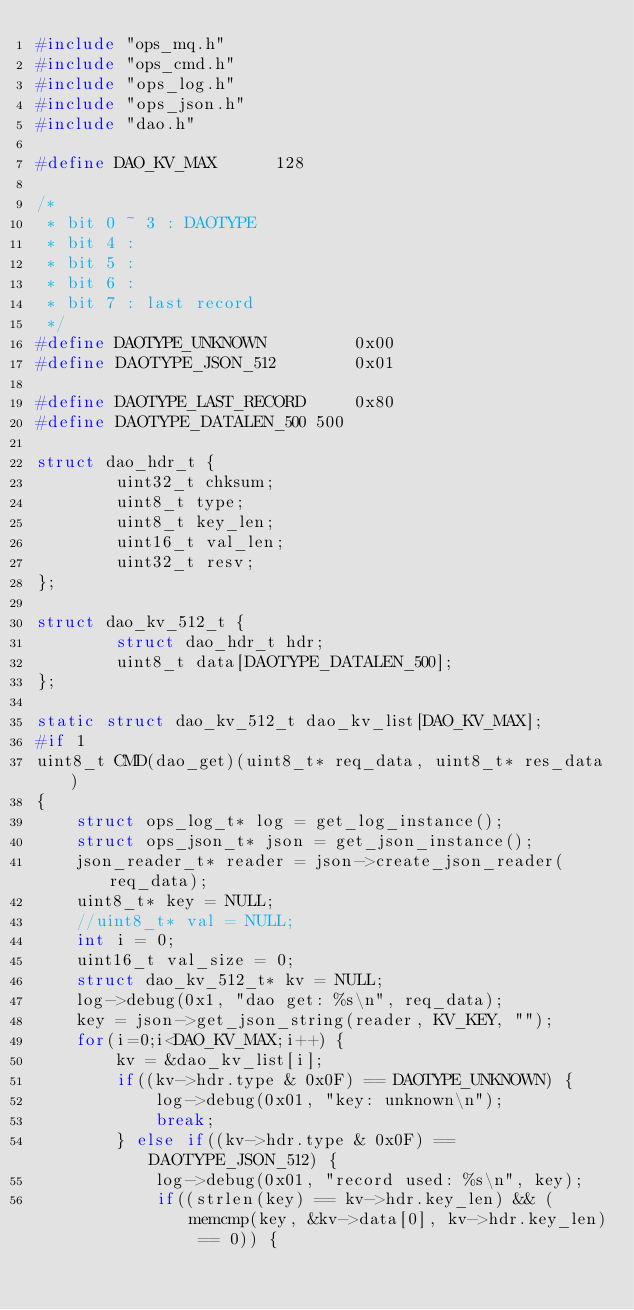Convert code to text. <code><loc_0><loc_0><loc_500><loc_500><_C_>#include "ops_mq.h"
#include "ops_cmd.h"
#include "ops_log.h"
#include "ops_json.h"
#include "dao.h"

#define DAO_KV_MAX      128

/*
 * bit 0 ~ 3 : DAOTYPE
 * bit 4 :
 * bit 5 :
 * bit 6 :
 * bit 7 : last record
 */
#define DAOTYPE_UNKNOWN         0x00
#define DAOTYPE_JSON_512        0x01

#define DAOTYPE_LAST_RECORD     0x80
#define DAOTYPE_DATALEN_500	500

struct dao_hdr_t {
        uint32_t chksum;
        uint8_t type;
        uint8_t key_len;
        uint16_t val_len;
        uint32_t resv;
};

struct dao_kv_512_t {
        struct dao_hdr_t hdr;
        uint8_t data[DAOTYPE_DATALEN_500];
};

static struct dao_kv_512_t dao_kv_list[DAO_KV_MAX];
#if 1
uint8_t CMD(dao_get)(uint8_t* req_data, uint8_t* res_data)
{
	struct ops_log_t* log = get_log_instance();
	struct ops_json_t* json = get_json_instance();
	json_reader_t* reader = json->create_json_reader(req_data);
	uint8_t* key = NULL;
	//uint8_t* val = NULL;
	int i = 0;
	uint16_t val_size = 0;
	struct dao_kv_512_t* kv = NULL;
	log->debug(0x1, "dao get: %s\n", req_data);
	key = json->get_json_string(reader, KV_KEY, "");
	for(i=0;i<DAO_KV_MAX;i++) {
		kv = &dao_kv_list[i];
		if((kv->hdr.type & 0x0F) == DAOTYPE_UNKNOWN) {
			log->debug(0x01, "key: unknown\n");
			break;
		} else if((kv->hdr.type & 0x0F) == DAOTYPE_JSON_512) {
			log->debug(0x01, "record used: %s\n", key);
			if((strlen(key) == kv->hdr.key_len) && (memcmp(key, &kv->data[0], kv->hdr.key_len) == 0)) {</code> 